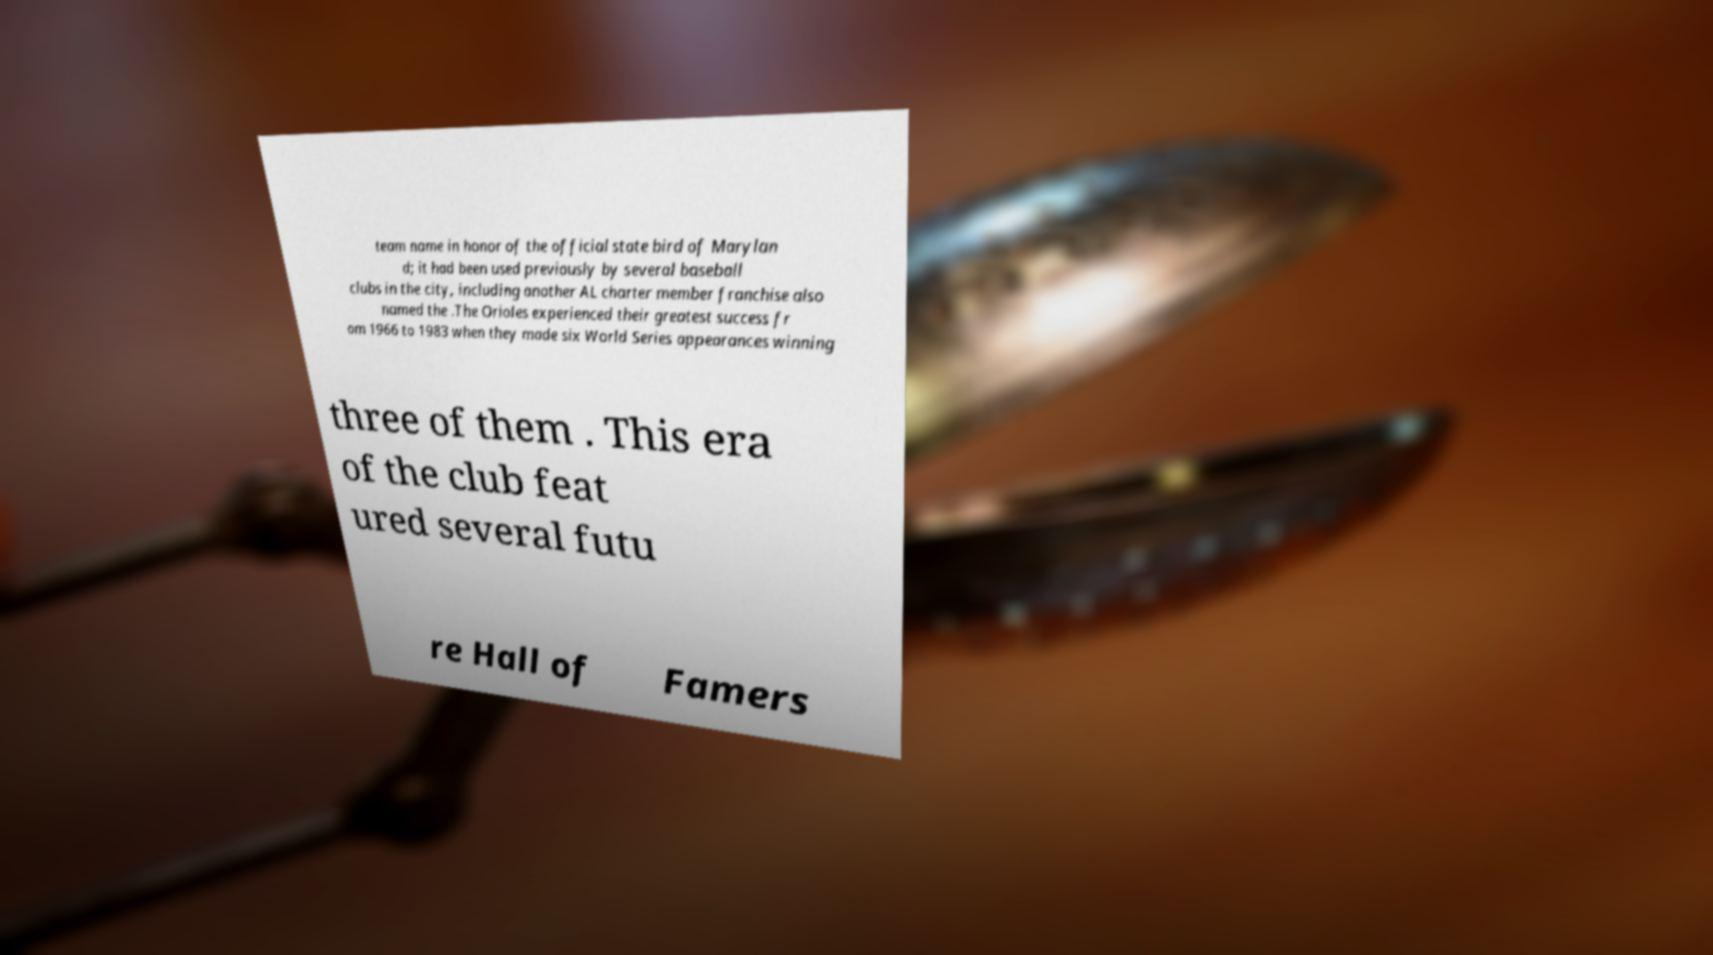Could you extract and type out the text from this image? team name in honor of the official state bird of Marylan d; it had been used previously by several baseball clubs in the city, including another AL charter member franchise also named the .The Orioles experienced their greatest success fr om 1966 to 1983 when they made six World Series appearances winning three of them . This era of the club feat ured several futu re Hall of Famers 